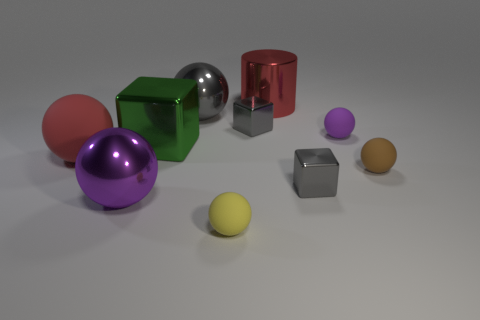There is a red object that is the same material as the green thing; what size is it?
Keep it short and to the point. Large. What number of matte things are either brown objects or small gray things?
Your answer should be very brief. 1. The red matte ball has what size?
Provide a short and direct response. Large. Do the shiny cylinder and the green metallic block have the same size?
Your answer should be very brief. Yes. There is a small purple ball that is behind the large purple metal thing; what is its material?
Make the answer very short. Rubber. There is a big purple thing that is the same shape as the yellow rubber object; what is its material?
Offer a very short reply. Metal. There is a large metal thing that is to the right of the yellow object; are there any red cylinders left of it?
Provide a short and direct response. No. Do the brown object and the small yellow thing have the same shape?
Provide a short and direct response. Yes. There is a large purple thing that is made of the same material as the big green object; what shape is it?
Your response must be concise. Sphere. Do the red object that is to the right of the tiny yellow ball and the matte thing that is to the left of the yellow ball have the same size?
Make the answer very short. Yes. 